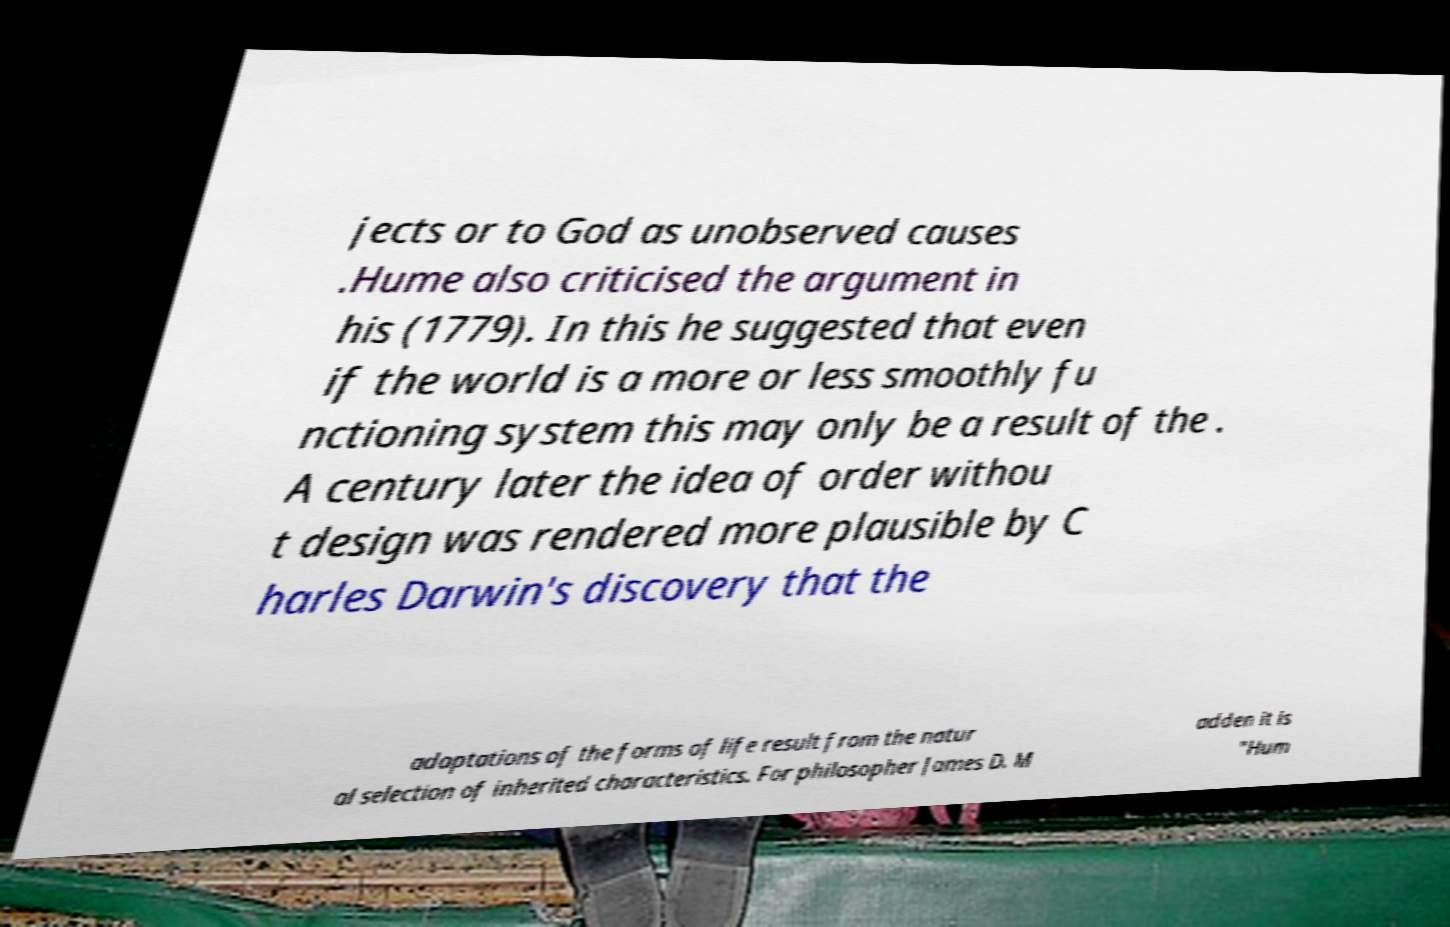There's text embedded in this image that I need extracted. Can you transcribe it verbatim? jects or to God as unobserved causes .Hume also criticised the argument in his (1779). In this he suggested that even if the world is a more or less smoothly fu nctioning system this may only be a result of the . A century later the idea of order withou t design was rendered more plausible by C harles Darwin's discovery that the adaptations of the forms of life result from the natur al selection of inherited characteristics. For philosopher James D. M adden it is "Hum 